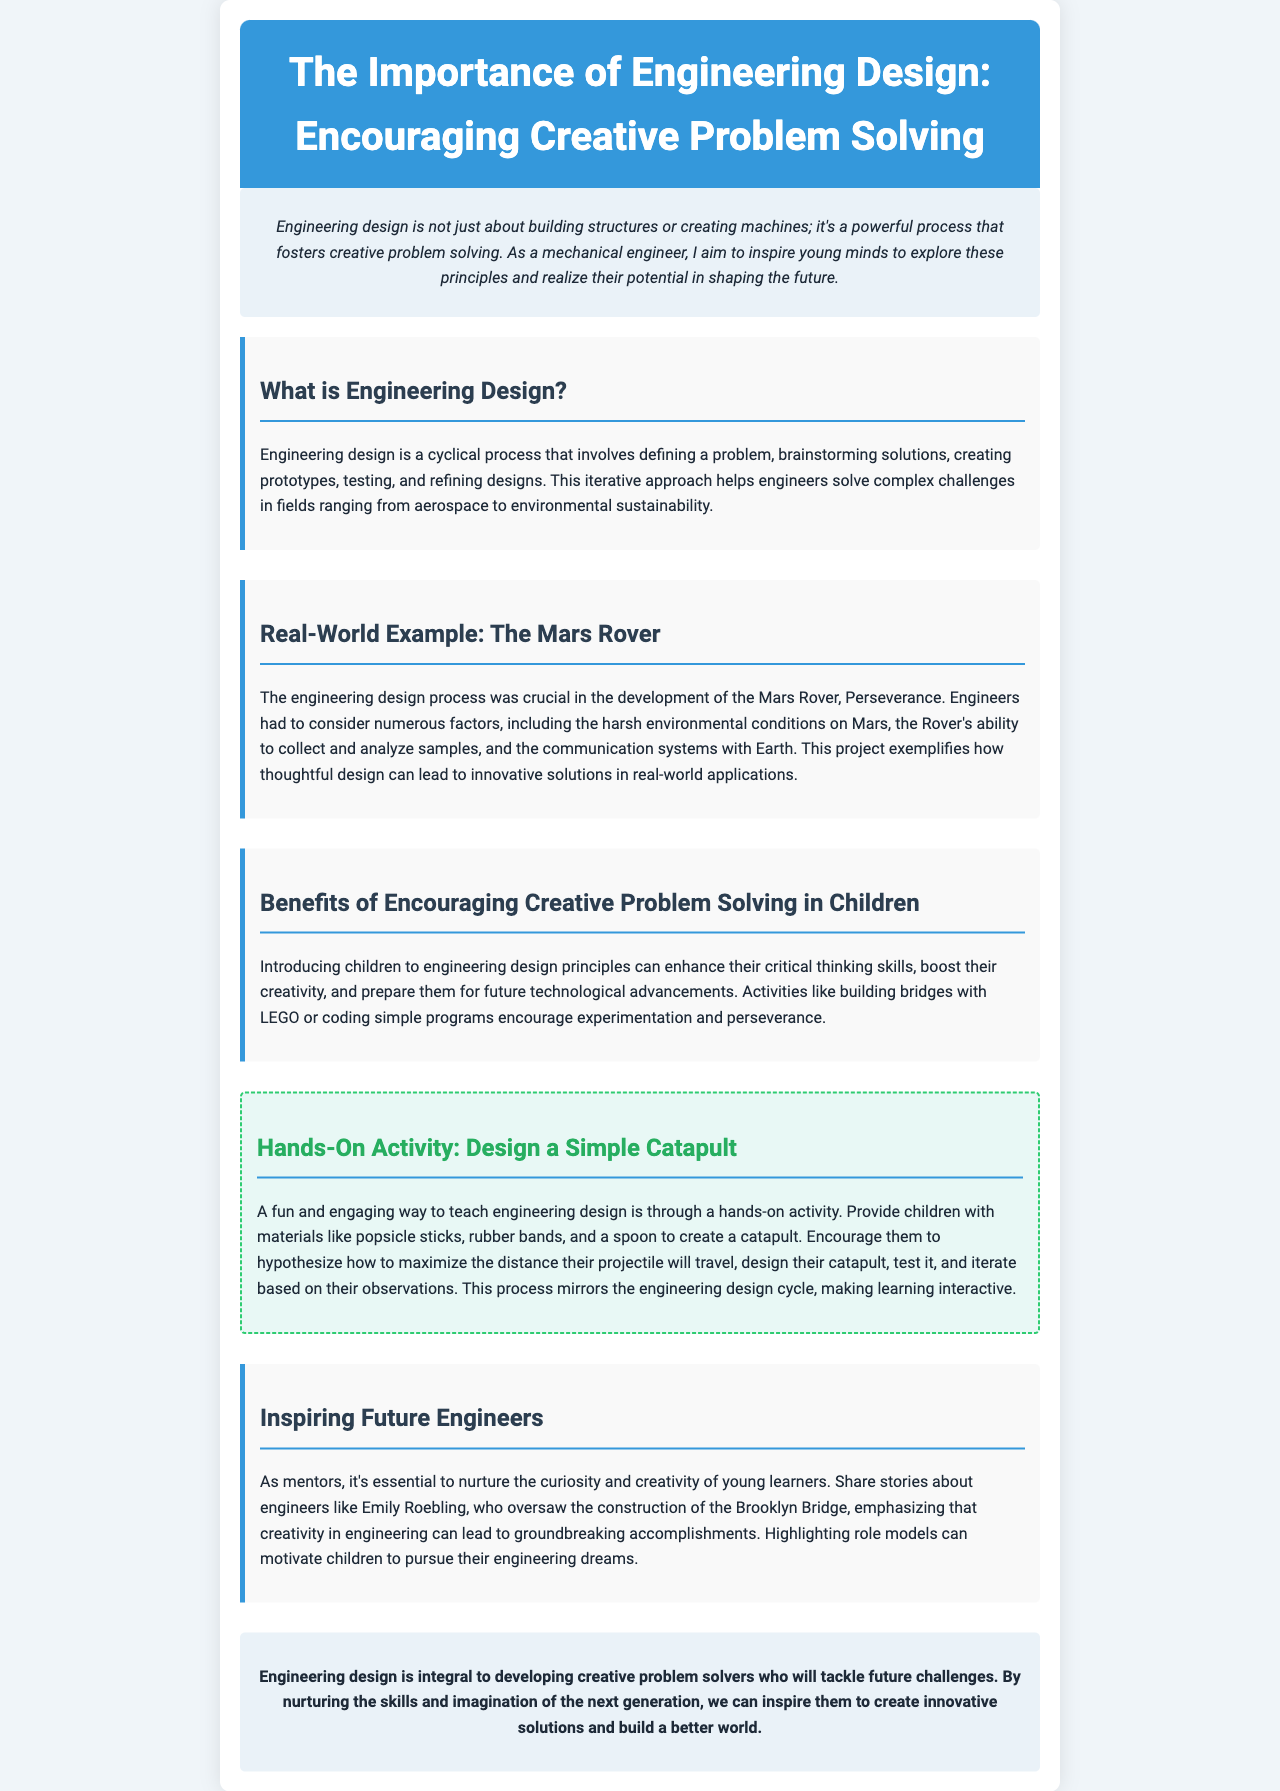What is the title of the newsletter? The title is clearly presented in the header of the document.
Answer: The Importance of Engineering Design: Encouraging Creative Problem Solving What does the engineering design process involve? The document outlines the main components involved in the engineering design process.
Answer: Defining a problem, brainstorming solutions, creating prototypes, testing, and refining designs Who is a notable engineer mentioned in the newsletter? The document highlights an engineer's contribution, showcasing an example to inspire young learners.
Answer: Emily Roebling What hands-on activity is suggested in the newsletter? The newsletter provides a specific activity aimed at teaching engineering concepts through practical involvement.
Answer: Design a Simple Catapult What is the main benefit of encouraging creative problem-solving in children? The document states the outcome of introducing children to engineering design principles.
Answer: Enhance critical thinking skills What project exemplifies the engineering design process? The newsletter describes a real-world application of the engineering design process through a specific project.
Answer: Mars Rover, Perseverance What skills can be developed through building bridges with LEGO? The document mentions activities through which children can grow their foundational skills.
Answer: Creativity What is the significance of the engineering design cycle according to the newsletter? The document emphasizes the importance of the design cycle in learning and experimentation processes.
Answer: It mirrors the engineering design cycle What is the concluding message of the newsletter? The conclusion summarizes the overall aim and importance of engineering design for future generations.
Answer: Inspire them to create innovative solutions and build a better world 